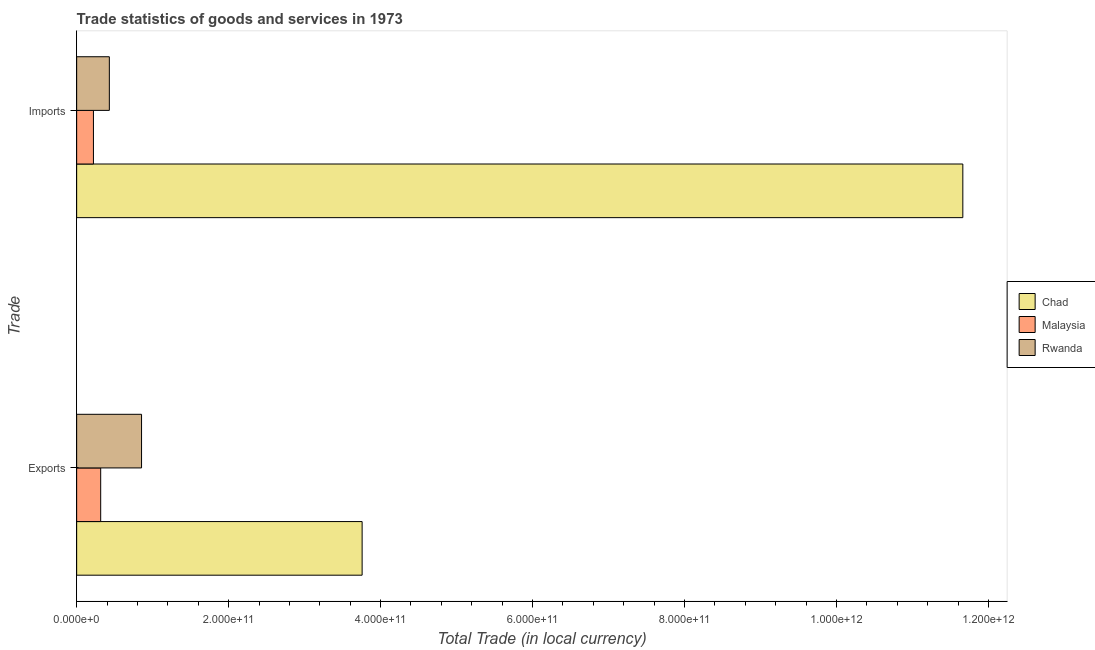How many different coloured bars are there?
Provide a succinct answer. 3. How many groups of bars are there?
Your answer should be compact. 2. Are the number of bars per tick equal to the number of legend labels?
Offer a terse response. Yes. How many bars are there on the 2nd tick from the top?
Your response must be concise. 3. How many bars are there on the 2nd tick from the bottom?
Offer a terse response. 3. What is the label of the 2nd group of bars from the top?
Offer a very short reply. Exports. What is the export of goods and services in Rwanda?
Provide a succinct answer. 8.54e+1. Across all countries, what is the maximum export of goods and services?
Offer a very short reply. 3.76e+11. Across all countries, what is the minimum imports of goods and services?
Give a very brief answer. 2.21e+1. In which country was the export of goods and services maximum?
Your answer should be compact. Chad. In which country was the imports of goods and services minimum?
Your response must be concise. Malaysia. What is the total imports of goods and services in the graph?
Give a very brief answer. 1.23e+12. What is the difference between the imports of goods and services in Malaysia and that in Rwanda?
Make the answer very short. -2.09e+1. What is the difference between the export of goods and services in Chad and the imports of goods and services in Rwanda?
Your answer should be very brief. 3.33e+11. What is the average export of goods and services per country?
Make the answer very short. 1.64e+11. What is the difference between the imports of goods and services and export of goods and services in Chad?
Offer a terse response. 7.91e+11. What is the ratio of the imports of goods and services in Malaysia to that in Rwanda?
Make the answer very short. 0.51. What does the 1st bar from the top in Exports represents?
Your response must be concise. Rwanda. What does the 1st bar from the bottom in Exports represents?
Provide a succinct answer. Chad. How many bars are there?
Provide a short and direct response. 6. How many countries are there in the graph?
Your answer should be very brief. 3. What is the difference between two consecutive major ticks on the X-axis?
Give a very brief answer. 2.00e+11. Are the values on the major ticks of X-axis written in scientific E-notation?
Your response must be concise. Yes. Does the graph contain any zero values?
Provide a short and direct response. No. Where does the legend appear in the graph?
Provide a short and direct response. Center right. How many legend labels are there?
Offer a terse response. 3. How are the legend labels stacked?
Give a very brief answer. Vertical. What is the title of the graph?
Make the answer very short. Trade statistics of goods and services in 1973. Does "Kazakhstan" appear as one of the legend labels in the graph?
Offer a very short reply. No. What is the label or title of the X-axis?
Your answer should be very brief. Total Trade (in local currency). What is the label or title of the Y-axis?
Your response must be concise. Trade. What is the Total Trade (in local currency) in Chad in Exports?
Offer a very short reply. 3.76e+11. What is the Total Trade (in local currency) of Malaysia in Exports?
Your answer should be very brief. 3.16e+1. What is the Total Trade (in local currency) of Rwanda in Exports?
Your answer should be very brief. 8.54e+1. What is the Total Trade (in local currency) of Chad in Imports?
Keep it short and to the point. 1.17e+12. What is the Total Trade (in local currency) of Malaysia in Imports?
Keep it short and to the point. 2.21e+1. What is the Total Trade (in local currency) of Rwanda in Imports?
Offer a terse response. 4.30e+1. Across all Trade, what is the maximum Total Trade (in local currency) of Chad?
Give a very brief answer. 1.17e+12. Across all Trade, what is the maximum Total Trade (in local currency) of Malaysia?
Make the answer very short. 3.16e+1. Across all Trade, what is the maximum Total Trade (in local currency) of Rwanda?
Your response must be concise. 8.54e+1. Across all Trade, what is the minimum Total Trade (in local currency) in Chad?
Your answer should be very brief. 3.76e+11. Across all Trade, what is the minimum Total Trade (in local currency) in Malaysia?
Your answer should be compact. 2.21e+1. Across all Trade, what is the minimum Total Trade (in local currency) of Rwanda?
Ensure brevity in your answer.  4.30e+1. What is the total Total Trade (in local currency) of Chad in the graph?
Provide a succinct answer. 1.54e+12. What is the total Total Trade (in local currency) of Malaysia in the graph?
Your answer should be compact. 5.37e+1. What is the total Total Trade (in local currency) of Rwanda in the graph?
Offer a very short reply. 1.28e+11. What is the difference between the Total Trade (in local currency) in Chad in Exports and that in Imports?
Give a very brief answer. -7.91e+11. What is the difference between the Total Trade (in local currency) of Malaysia in Exports and that in Imports?
Your response must be concise. 9.53e+09. What is the difference between the Total Trade (in local currency) of Rwanda in Exports and that in Imports?
Your response must be concise. 4.24e+1. What is the difference between the Total Trade (in local currency) of Chad in Exports and the Total Trade (in local currency) of Malaysia in Imports?
Ensure brevity in your answer.  3.54e+11. What is the difference between the Total Trade (in local currency) in Chad in Exports and the Total Trade (in local currency) in Rwanda in Imports?
Give a very brief answer. 3.33e+11. What is the difference between the Total Trade (in local currency) of Malaysia in Exports and the Total Trade (in local currency) of Rwanda in Imports?
Offer a very short reply. -1.14e+1. What is the average Total Trade (in local currency) in Chad per Trade?
Ensure brevity in your answer.  7.71e+11. What is the average Total Trade (in local currency) of Malaysia per Trade?
Offer a terse response. 2.69e+1. What is the average Total Trade (in local currency) of Rwanda per Trade?
Make the answer very short. 6.42e+1. What is the difference between the Total Trade (in local currency) of Chad and Total Trade (in local currency) of Malaysia in Exports?
Offer a very short reply. 3.44e+11. What is the difference between the Total Trade (in local currency) in Chad and Total Trade (in local currency) in Rwanda in Exports?
Your answer should be compact. 2.90e+11. What is the difference between the Total Trade (in local currency) in Malaysia and Total Trade (in local currency) in Rwanda in Exports?
Your answer should be very brief. -5.38e+1. What is the difference between the Total Trade (in local currency) of Chad and Total Trade (in local currency) of Malaysia in Imports?
Provide a succinct answer. 1.14e+12. What is the difference between the Total Trade (in local currency) of Chad and Total Trade (in local currency) of Rwanda in Imports?
Your response must be concise. 1.12e+12. What is the difference between the Total Trade (in local currency) of Malaysia and Total Trade (in local currency) of Rwanda in Imports?
Your answer should be very brief. -2.09e+1. What is the ratio of the Total Trade (in local currency) of Chad in Exports to that in Imports?
Make the answer very short. 0.32. What is the ratio of the Total Trade (in local currency) of Malaysia in Exports to that in Imports?
Offer a very short reply. 1.43. What is the ratio of the Total Trade (in local currency) in Rwanda in Exports to that in Imports?
Provide a short and direct response. 1.99. What is the difference between the highest and the second highest Total Trade (in local currency) of Chad?
Keep it short and to the point. 7.91e+11. What is the difference between the highest and the second highest Total Trade (in local currency) in Malaysia?
Provide a short and direct response. 9.53e+09. What is the difference between the highest and the second highest Total Trade (in local currency) in Rwanda?
Your answer should be very brief. 4.24e+1. What is the difference between the highest and the lowest Total Trade (in local currency) in Chad?
Provide a short and direct response. 7.91e+11. What is the difference between the highest and the lowest Total Trade (in local currency) of Malaysia?
Make the answer very short. 9.53e+09. What is the difference between the highest and the lowest Total Trade (in local currency) in Rwanda?
Offer a terse response. 4.24e+1. 